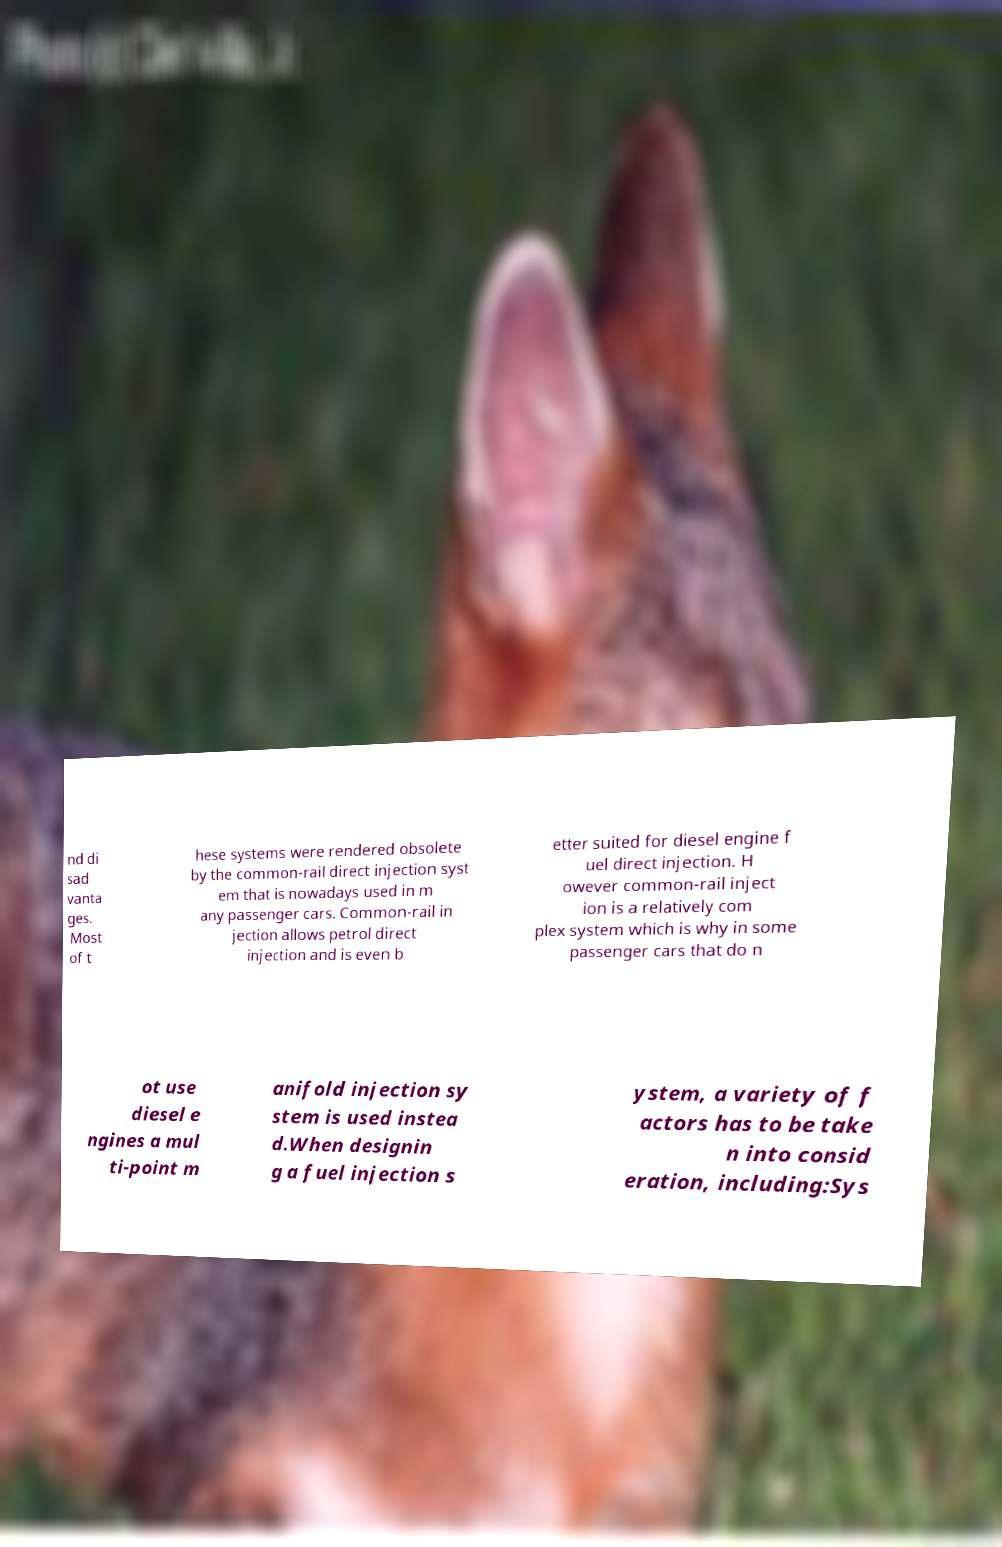What messages or text are displayed in this image? I need them in a readable, typed format. nd di sad vanta ges. Most of t hese systems were rendered obsolete by the common-rail direct injection syst em that is nowadays used in m any passenger cars. Common-rail in jection allows petrol direct injection and is even b etter suited for diesel engine f uel direct injection. H owever common-rail inject ion is a relatively com plex system which is why in some passenger cars that do n ot use diesel e ngines a mul ti-point m anifold injection sy stem is used instea d.When designin g a fuel injection s ystem, a variety of f actors has to be take n into consid eration, including:Sys 